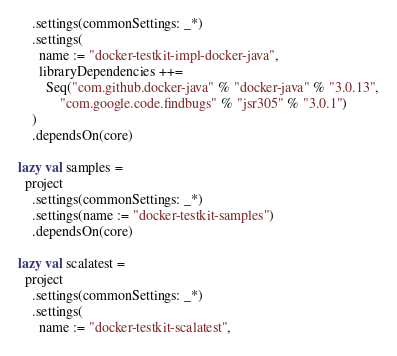Convert code to text. <code><loc_0><loc_0><loc_500><loc_500><_Scala_>    .settings(commonSettings: _*)
    .settings(
      name := "docker-testkit-impl-docker-java",
      libraryDependencies ++=
        Seq("com.github.docker-java" % "docker-java" % "3.0.13",
            "com.google.code.findbugs" % "jsr305" % "3.0.1")
    )
    .dependsOn(core)

lazy val samples =
  project
    .settings(commonSettings: _*)
    .settings(name := "docker-testkit-samples")
    .dependsOn(core)

lazy val scalatest =
  project
    .settings(commonSettings: _*)
    .settings(
      name := "docker-testkit-scalatest",</code> 